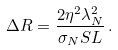<formula> <loc_0><loc_0><loc_500><loc_500>\Delta R = \frac { 2 \eta ^ { 2 } \lambda _ { N } ^ { 2 } } { \sigma _ { N } S L } \, .</formula> 